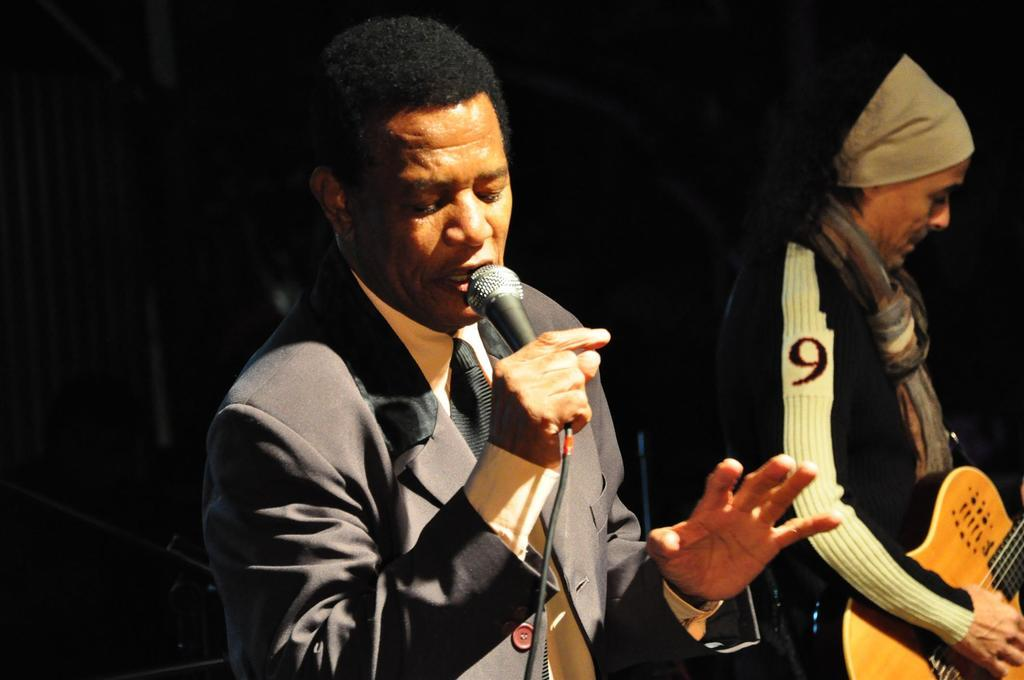How many people are present in the image? There are two people in the image. What are the people doing in the image? One person is singing with the help of a microphone, and another person is playing a guitar. What color is the sweater worn by the person playing the guitar in the image? There is no information about the color of a sweater or any clothing worn by the people in the image. 